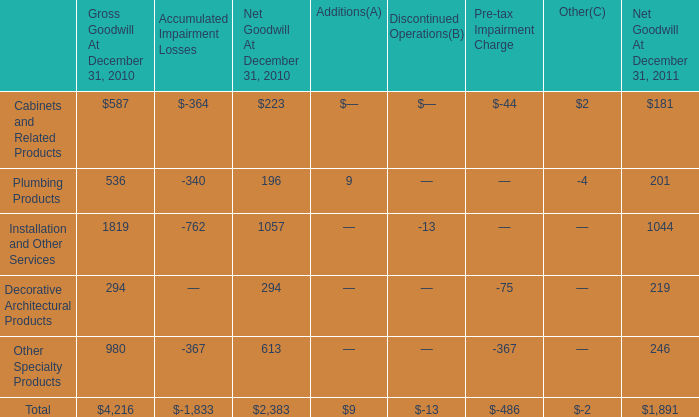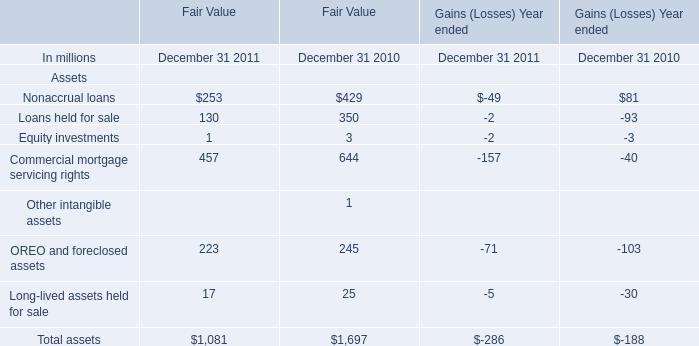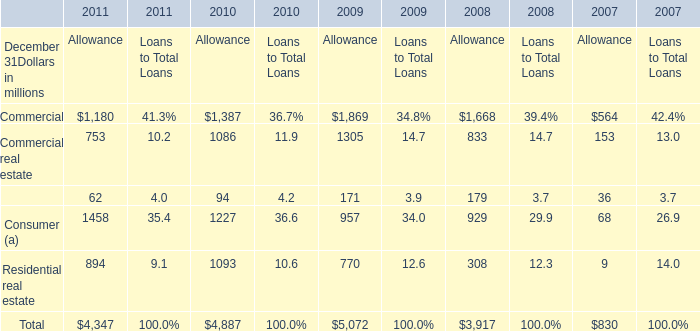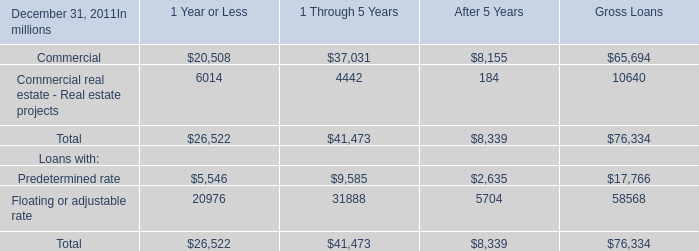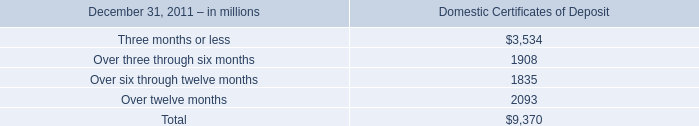what was the percentage change in total net goodwill between 2010 and 2011? 
Computations: ((1891 - 2383) / 2383)
Answer: -0.20646. 